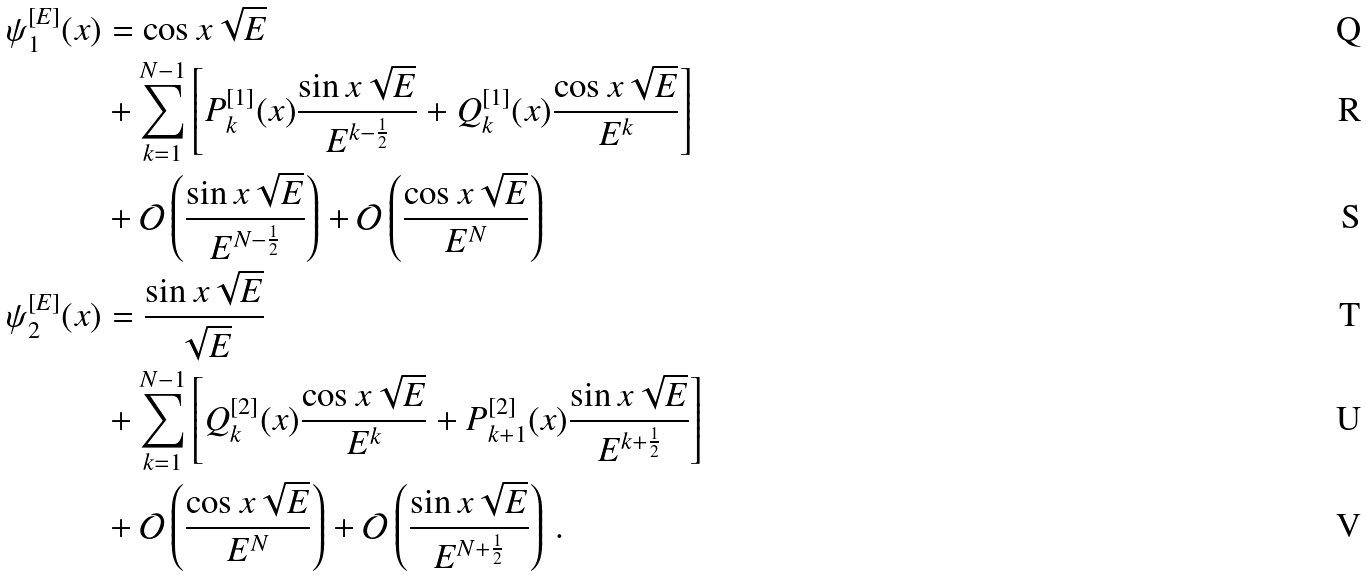Convert formula to latex. <formula><loc_0><loc_0><loc_500><loc_500>\psi _ { 1 } ^ { [ E ] } ( x ) & = \cos x \sqrt { E } \\ & + \sum _ { k = 1 } ^ { N - 1 } \left [ P _ { k } ^ { [ 1 ] } ( x ) \frac { \sin x \sqrt { E } } { E ^ { k - \frac { 1 } { 2 } } } + Q _ { k } ^ { [ 1 ] } ( x ) \frac { \cos x \sqrt { E } } { E ^ { k } } \right ] \\ & + \mathcal { O } \left ( \frac { \sin x \sqrt { E } } { E ^ { N - \frac { 1 } { 2 } } } \right ) + \mathcal { O } \left ( \frac { \cos x \sqrt { E } } { E ^ { N } } \right ) \\ \psi _ { 2 } ^ { [ E ] } ( x ) & = \frac { \sin x \sqrt { E } } { \sqrt { E } } \\ & + \sum _ { k = 1 } ^ { N - 1 } \left [ Q _ { k } ^ { [ 2 ] } ( x ) \frac { \cos x \sqrt { E } } { E ^ { k } } + P _ { k + 1 } ^ { [ 2 ] } ( x ) \frac { \sin x \sqrt { E } } { E ^ { k + \frac { 1 } { 2 } } } \right ] \\ & + \mathcal { O } \left ( \frac { \cos x \sqrt { E } } { E ^ { N } } \right ) + \mathcal { O } \left ( \frac { \sin x \sqrt { E } } { E ^ { N + \frac { 1 } { 2 } } } \right ) \, .</formula> 